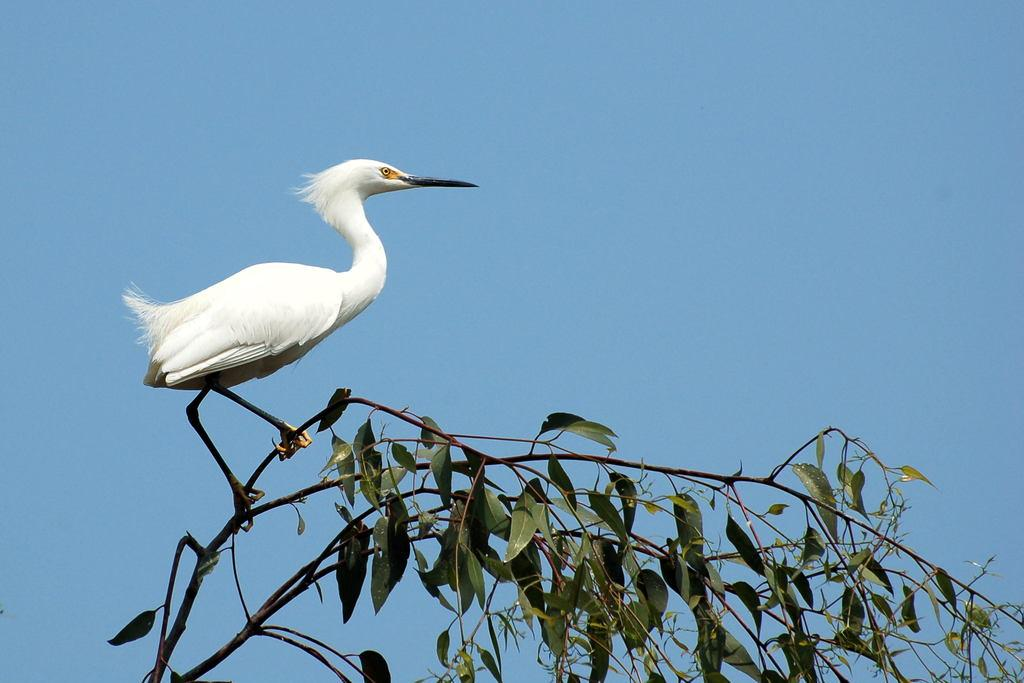What type of animal is in the image? There is a white color bird in the image. Where is the bird located? The bird is on a tree. What is the closest object to the viewer in the image? There is a tree in the foreground of the image. What can be seen at the top of the image? The sky is visible at the top of the image. Can you tell me how many cows are grazing on the land in the image? There are no cows or land visible in the image; it features a bird on a tree with a visible sky. 